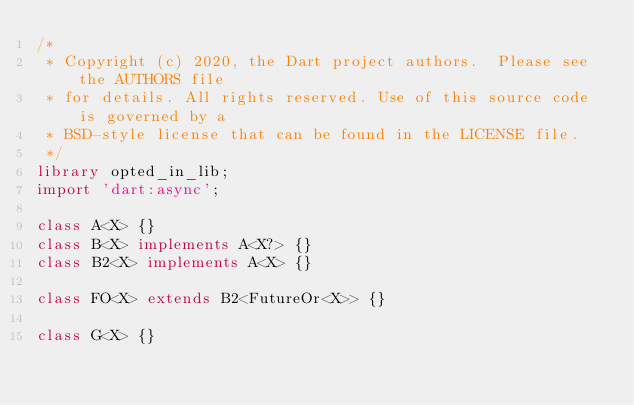Convert code to text. <code><loc_0><loc_0><loc_500><loc_500><_Dart_>/*
 * Copyright (c) 2020, the Dart project authors.  Please see the AUTHORS file
 * for details. All rights reserved. Use of this source code is governed by a
 * BSD-style license that can be found in the LICENSE file.
 */
library opted_in_lib;
import 'dart:async';

class A<X> {}
class B<X> implements A<X?> {}
class B2<X> implements A<X> {}

class FO<X> extends B2<FutureOr<X>> {}

class G<X> {}
</code> 